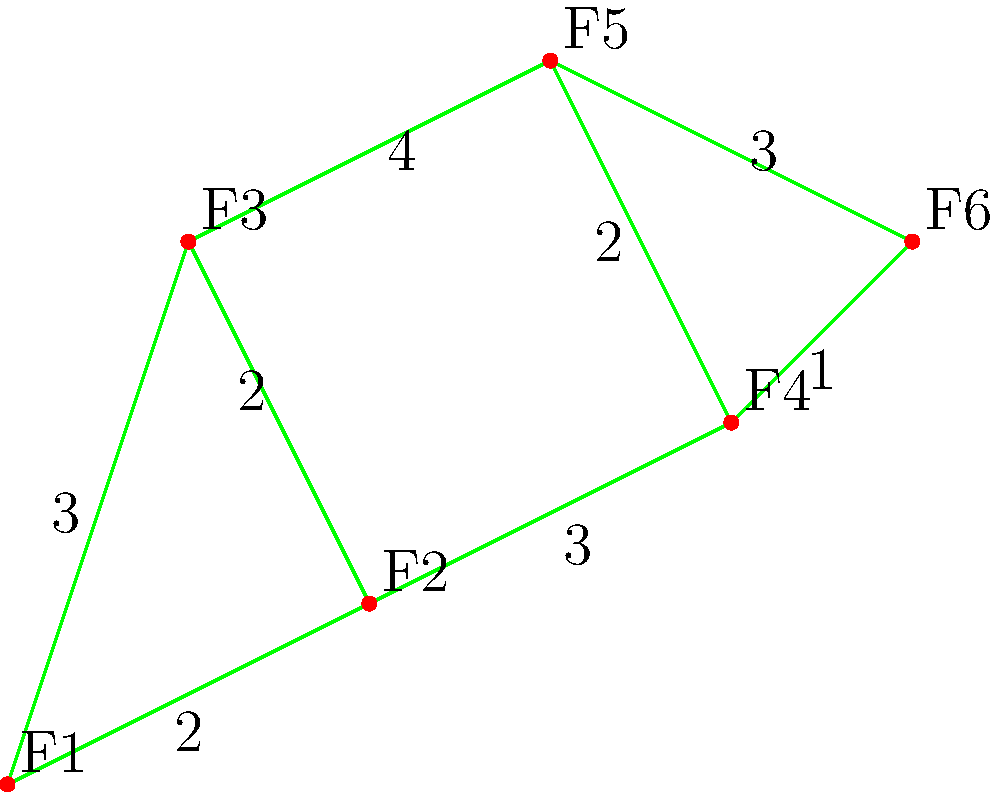In a garden, six flowers (F1 to F6) are connected by paths as shown in the graph. The numbers on the edges represent the time (in minutes) it takes for a pollinator insect to travel between flowers. What is the shortest time required for the insect to travel from F1 to F6? To find the shortest path from F1 to F6, we can use Dijkstra's algorithm:

1. Initialize:
   - Distance to F1 = 0
   - Distance to all other flowers = infinity
   - Set of unvisited flowers = {F1, F2, F3, F4, F5, F6}

2. From F1:
   - Update F2: min(∞, 0 + 2) = 2
   - Update F3: min(∞, 0 + 3) = 3
   - Mark F1 as visited

3. Select F2 (shortest distance):
   - Update F3: min(3, 2 + 2) = 3 (no change)
   - Update F4: min(∞, 2 + 3) = 5
   - Mark F2 as visited

4. Select F3:
   - Update F5: min(∞, 3 + 4) = 7
   - Mark F3 as visited

5. Select F4:
   - Update F5: min(7, 5 + 2) = 7 (no change)
   - Update F6: min(∞, 5 + 1) = 6
   - Mark F4 as visited

6. Select F6:
   - Destination reached

The shortest path is F1 → F2 → F4 → F6, with a total time of 6 minutes.
Answer: 6 minutes 